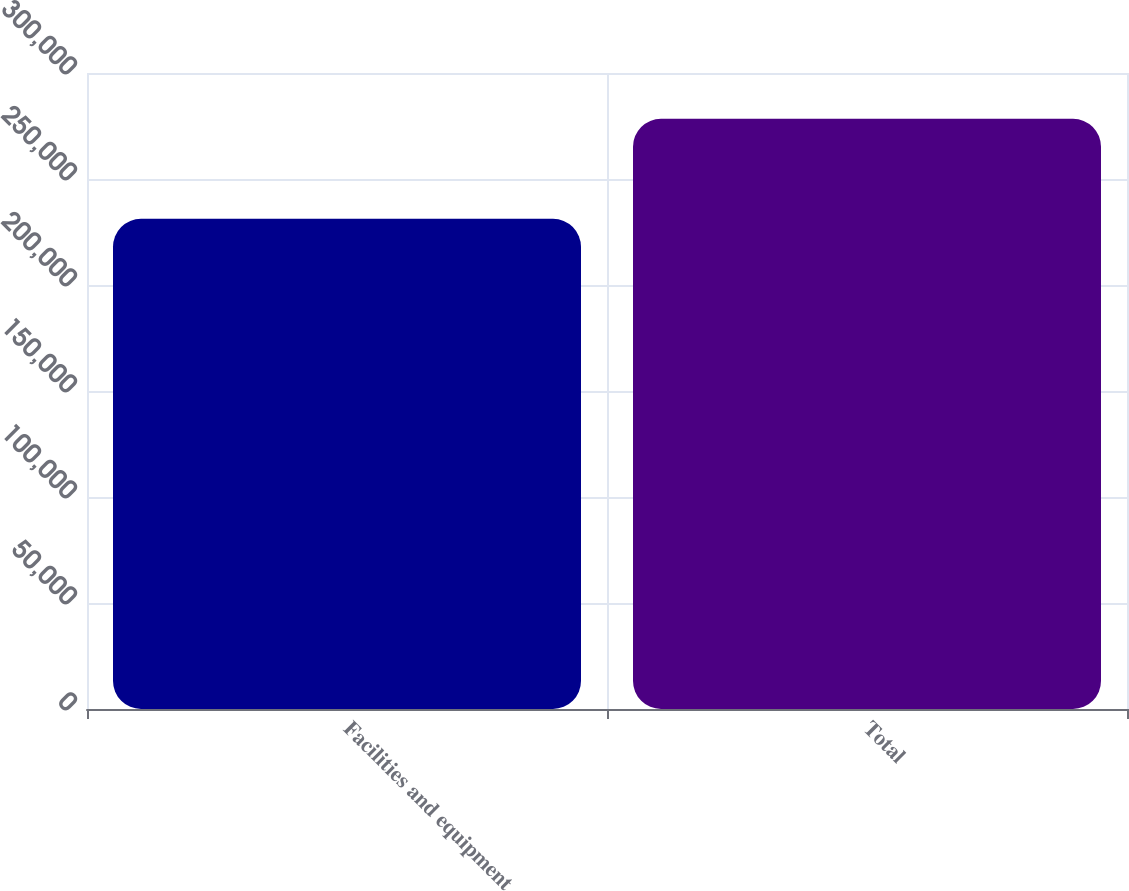Convert chart to OTSL. <chart><loc_0><loc_0><loc_500><loc_500><bar_chart><fcel>Facilities and equipment<fcel>Total<nl><fcel>231200<fcel>278386<nl></chart> 